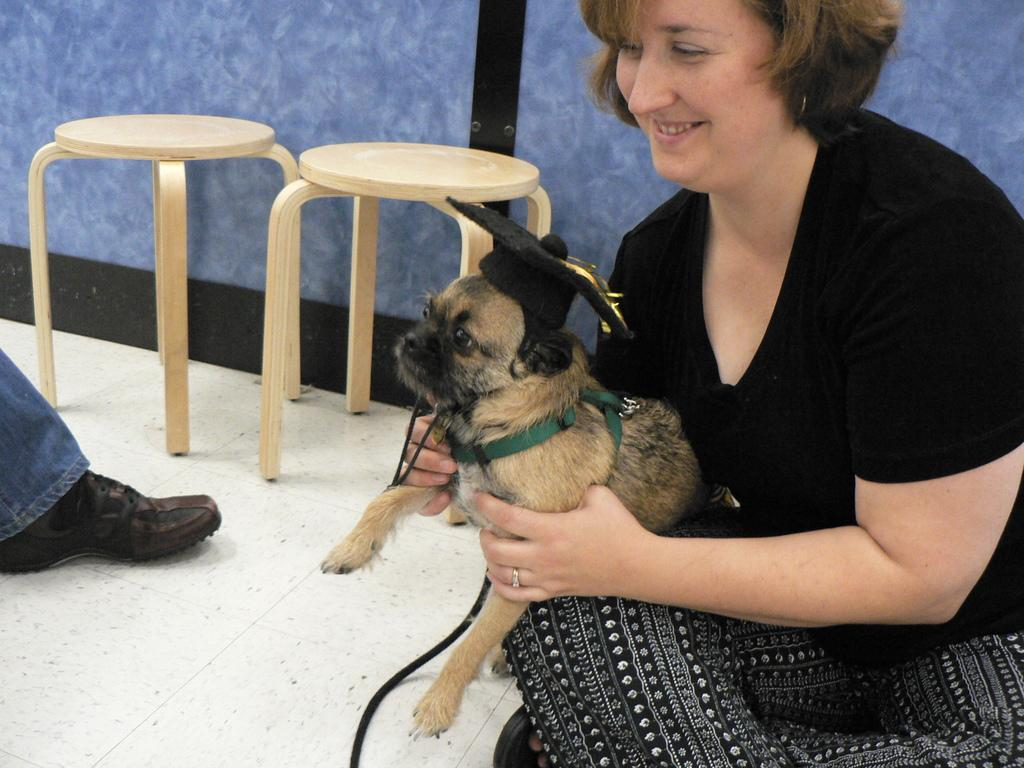Who is present in the image? There is a woman in the image. What is the woman doing? The woman is smiling and holding a dog. How many stools are in the image? There are 2 stools in the image. What part of a person can be seen in the image? A person's leg is visible in the image. What can be seen in the background of the image? There is a wall in the background of the image. What type of class is being taught in the image? There is no class or teaching activity present in the image. How many account numbers are visible in the image? There are no account numbers visible in the image. 